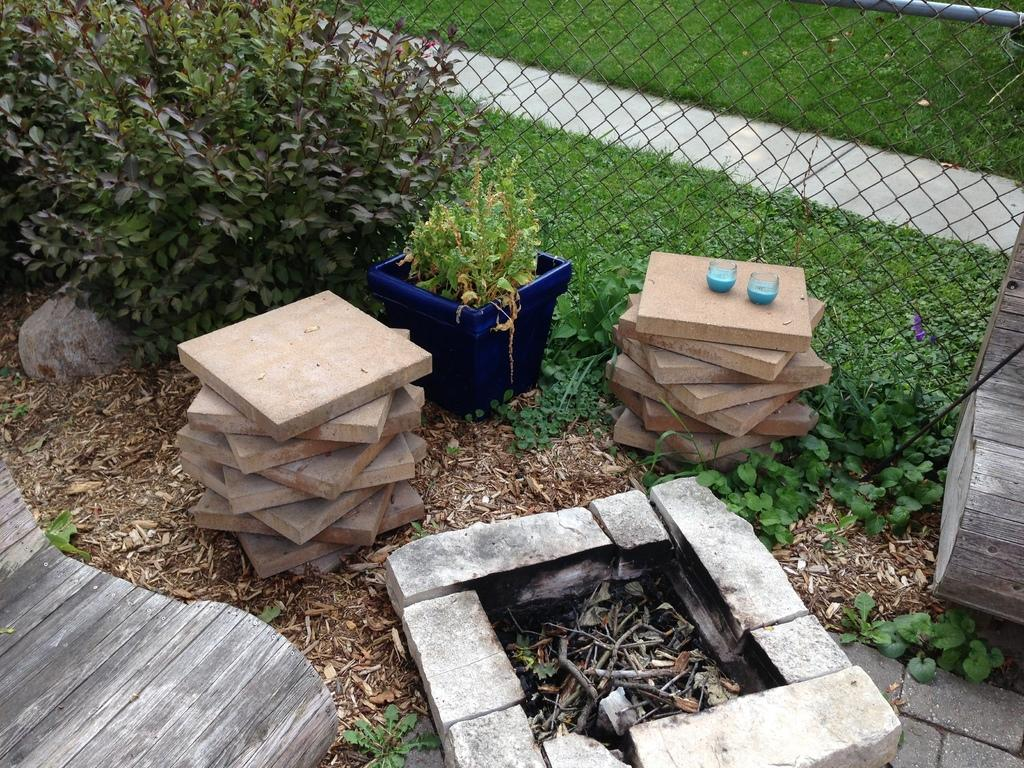What is the main feature in the middle of the image? There is a camp fire pit in the middle of the image. What is located on either side of the camp fire pit? There are wooden blocks on either side of the camp fire pit. What type of vegetation is near the camp fire pit? There are plants beside the camp fire pit. What type of barrier can be seen in the image? There is a fence visible in the image. What type of terrain is visible in the front of the camp fire pit? There is grassland in the front of the image. What type of cushion is used to extinguish the spark from the camp fire pit? There is no cushion present in the image, and sparks are not mentioned as part of the camp fire pit's features. 